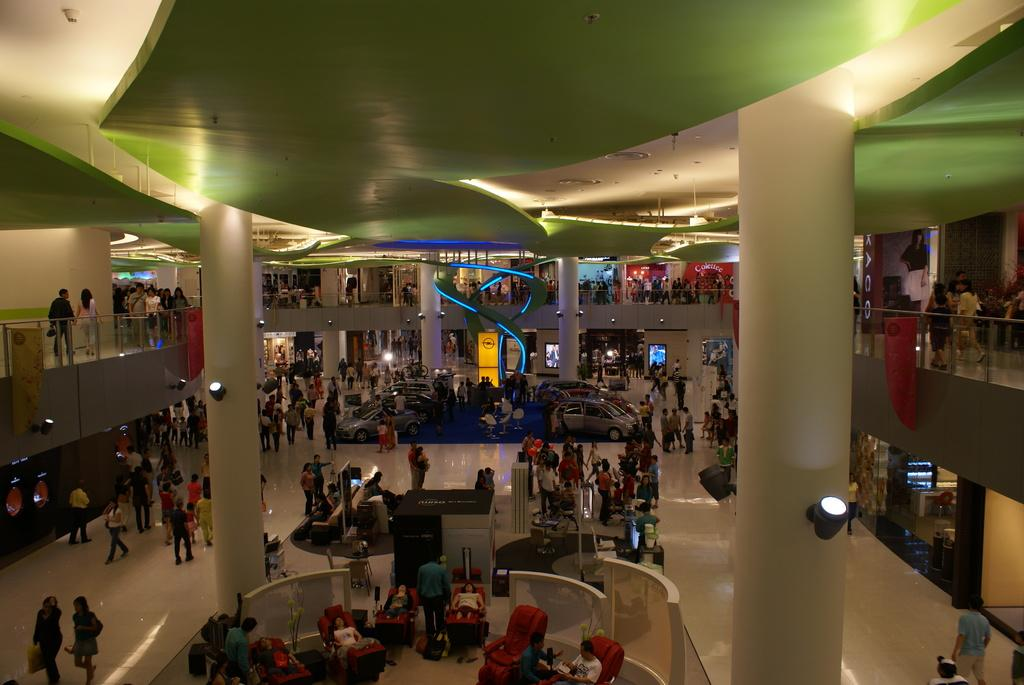How many people can be seen in the image? There are people in the image, but the exact number cannot be determined from the provided facts. What type of furniture is present in the image? Chairs, sofas, and possibly other types of furniture can be seen in the image. What kind of lighting is visible in the image? There are lights in the image, but their specific type or style cannot be determined. What architectural elements are present in the image? Pillars and glass railing can be seen in the image. What type of signage is visible in the image? Hoardings and banners are present in the image. What is the floor like in the image? There is a floor visible in the image, but its material or design cannot be determined. What is the most unusual item in the image? Cars on the carpet can be seen in the image, which is an unusual sight. What type of ship can be seen sailing in the image? There is no ship present in the image; it features people, furniture, and various architectural elements. 